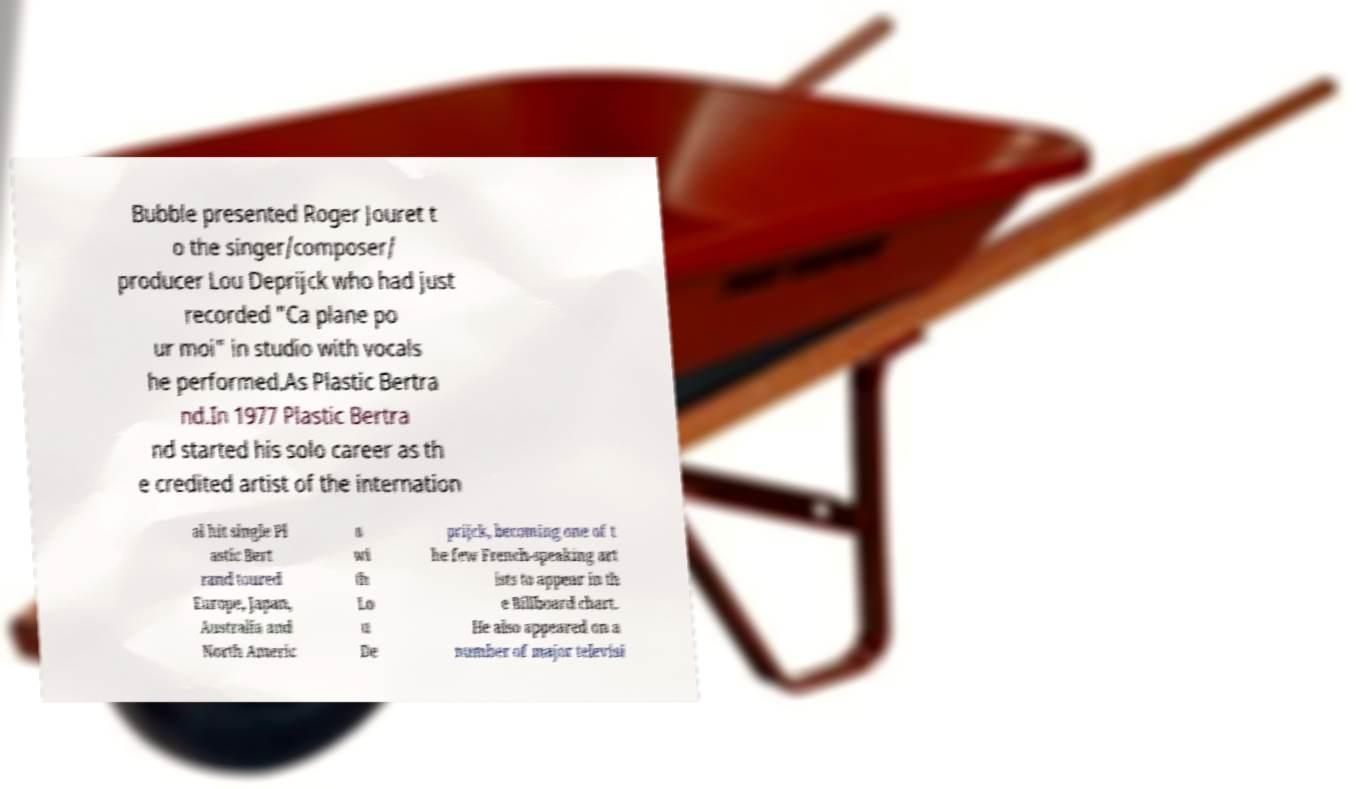There's text embedded in this image that I need extracted. Can you transcribe it verbatim? Bubble presented Roger Jouret t o the singer/composer/ producer Lou Deprijck who had just recorded "Ca plane po ur moi" in studio with vocals he performed.As Plastic Bertra nd.In 1977 Plastic Bertra nd started his solo career as th e credited artist of the internation al hit single Pl astic Bert rand toured Europe, Japan, Australia and North Americ a wi th Lo u De prijck, becoming one of t he few French-speaking art ists to appear in th e Billboard chart. He also appeared on a number of major televisi 